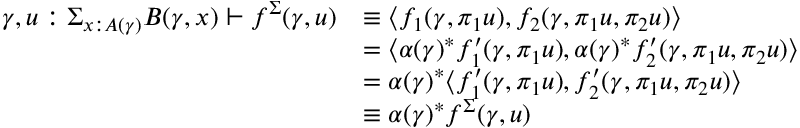<formula> <loc_0><loc_0><loc_500><loc_500>\begin{array} { r l } { \gamma , u \colon \Sigma _ { x \colon A ( \gamma ) } B ( \gamma , x ) \vdash f ^ { \Sigma } ( \gamma , u ) } & { \equiv \langle f _ { 1 } ( \gamma , \pi _ { 1 } u ) , f _ { 2 } ( \gamma , \pi _ { 1 } u , \pi _ { 2 } u ) \rangle } \\ & { = \langle \alpha ( \gamma ) ^ { * } f _ { 1 } ^ { \prime } ( \gamma , \pi _ { 1 } u ) , \alpha ( \gamma ) ^ { * } f _ { 2 } ^ { \prime } ( \gamma , \pi _ { 1 } u , \pi _ { 2 } u ) \rangle } \\ & { = \alpha ( \gamma ) ^ { * } \langle f _ { 1 } ^ { \prime } ( \gamma , \pi _ { 1 } u ) , f _ { 2 } ^ { \prime } ( \gamma , \pi _ { 1 } u , \pi _ { 2 } u ) \rangle } \\ & { \equiv \alpha ( \gamma ) ^ { * } f ^ { \Sigma } ( \gamma , u ) } \end{array}</formula> 